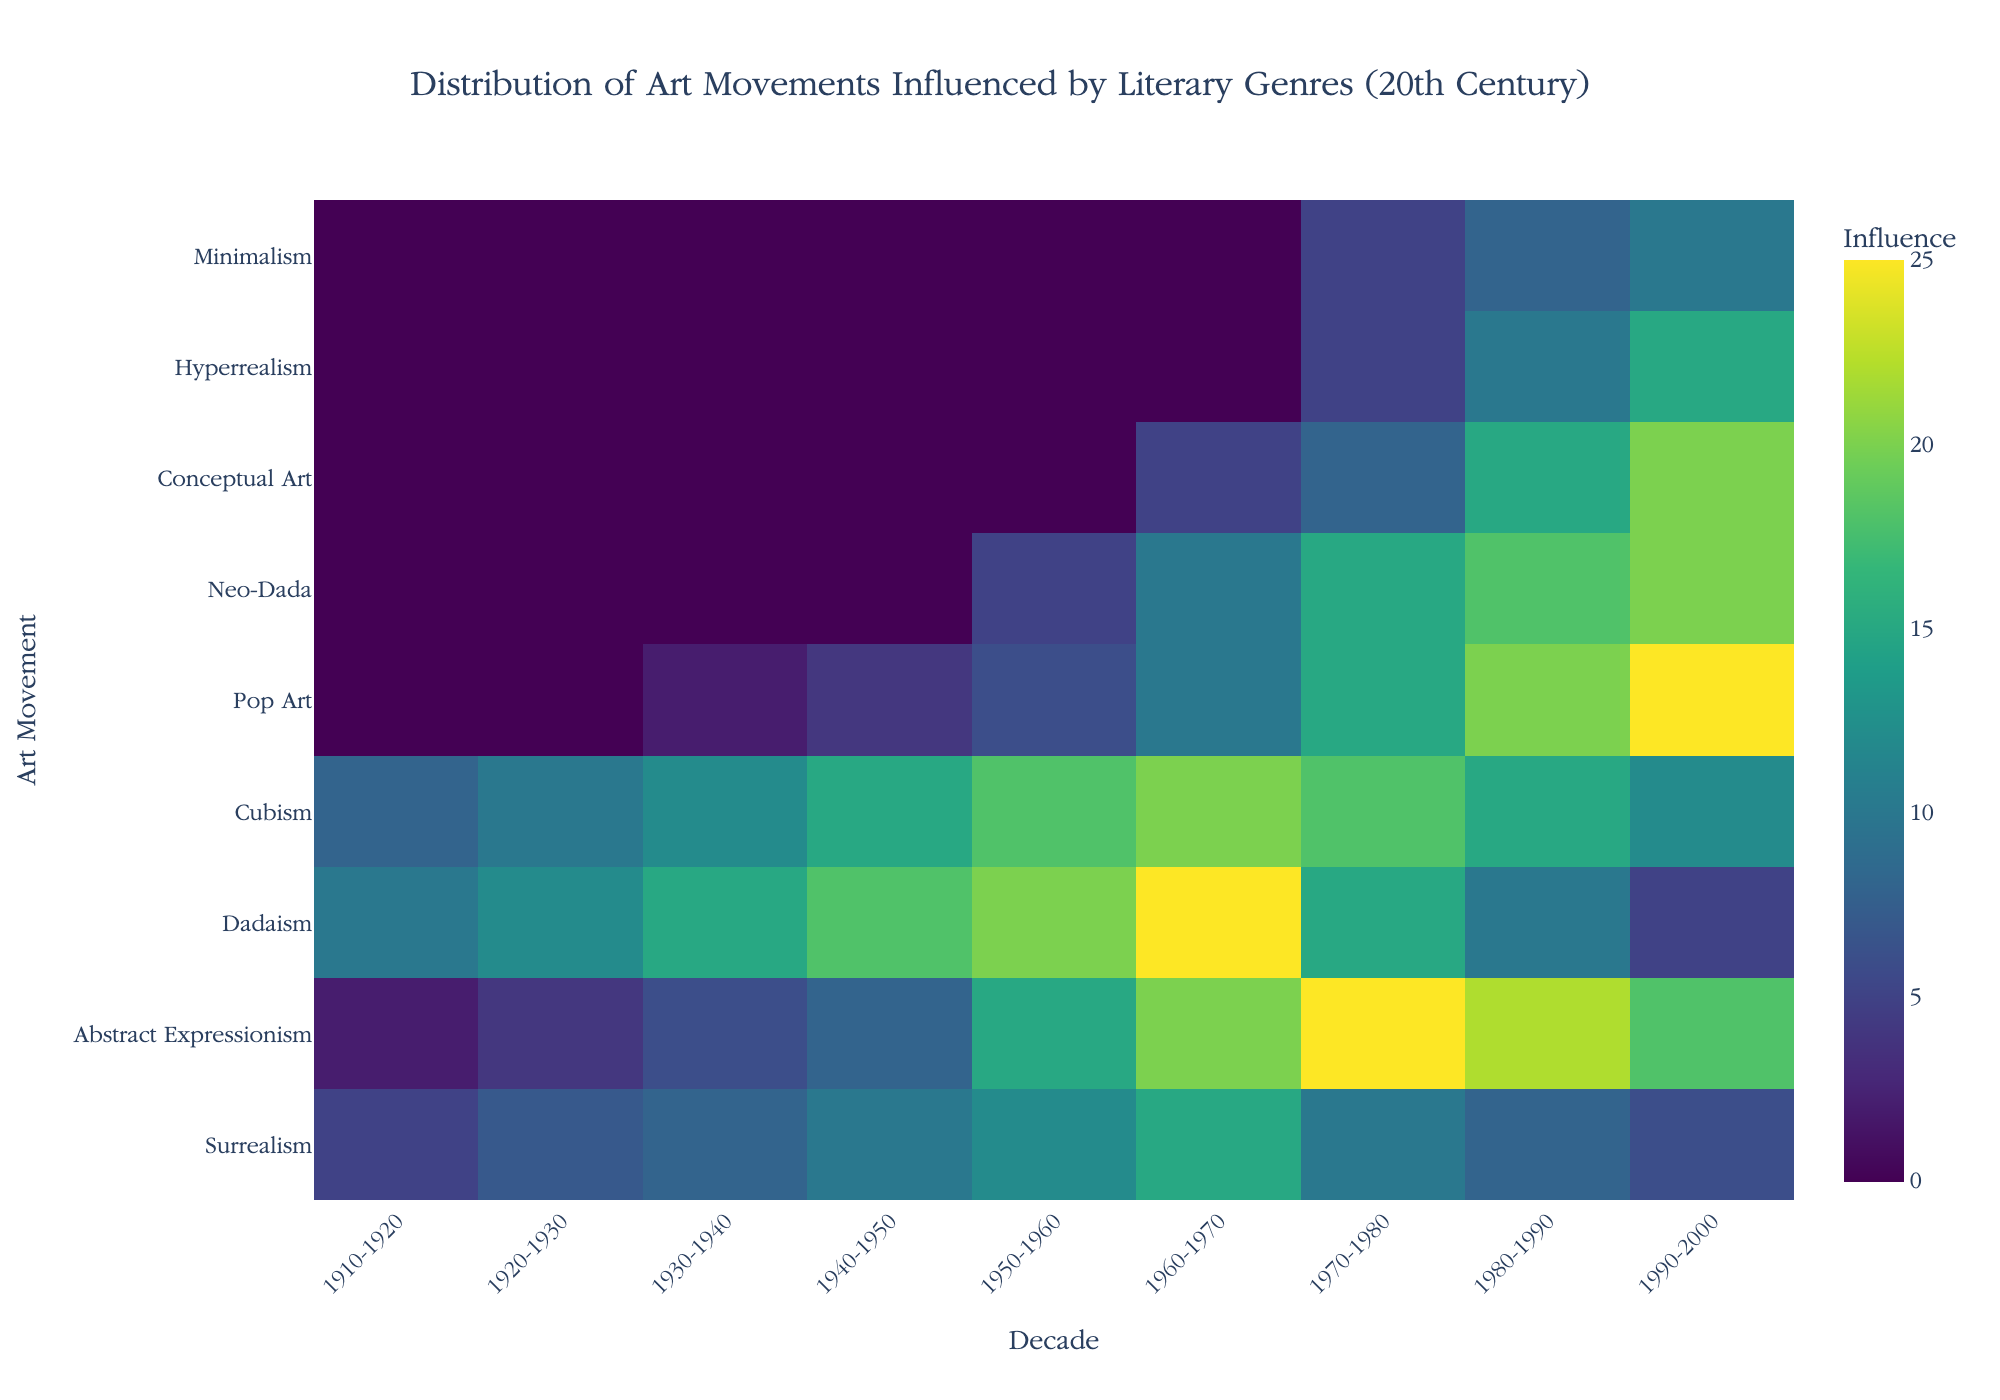What's the title of the heatmap? The title is specified in the layout section under `title`. It reads: "Distribution of Art Movements Influenced by Literary Genres (20th Century)".
Answer: Distribution of Art Movements Influenced by Literary Genres (20th Century) Which art movement shows the highest influence from the Beat Generation? On the y-axis, find "Pop Art", and observe the color intensity in the corresponding row. The highest value appears in the 1990-2000 decade.
Answer: Pop Art In which decade did Dadaism reach its peak influence? Locate the "Dadaism" row on the y-axis and identify the decade with the darkest color for this row. It peaks in the 1960-1970 decade.
Answer: 1960-1970 Compare the influence of Abstract Expressionism from American Modernism in the 1950-1960 decade to that in the 1990-2000 decade. Which decade had higher influence? Locate "Abstract Expressionism" in the y-axis and compare the color intensity for the decades 1950-1960 and 1990-2000. The 1950-1960 decade shows higher influence.
Answer: 1950-1960 Which art movement has a recorded influence only in the 1980-1990 decade from Postmodern Literature? Locate the column for 1980-1990 and find the row "Conceptual Art" on the y-axis.
Answer: Conceptual Art Summarize the influence of New Journalism on art movements in the latter half of the 20th century (1950-2000). "Hyperrealism" is the art movement influenced by "New Journalism". From 1950-1960 to 1990-2000, the color intensity increases, indicating rising influence within those decades.
Answer: Rising influence from 1960-2000 What's the combined influence score of Surrealism from French Symbolism across the entire 20th century? Sum up the influence values from 1910-1920 to 1990-2000 for Surrealism: 5 + 7 + 8 + 10 + 12 + 15 + 10 + 8 + 6. The total is 81.
Answer: 81 Which literary genre had no influence on any art movement until the 1950-1960 decade? Examine the rows to see which start showing influence only from the 1950-1960 decade onwards. "Absurdist Fiction" influencing "Neo-Dada" fits this criterion.
Answer: Absurdist Fiction Which art movements show influence from Minimalist Literature and in which decades? Observing "Minimalism" on the y-axis shows influence in the decades 1970-1980, 1980-1990, and 1990-2000.
Answer: Minimalism (1970-2000) 